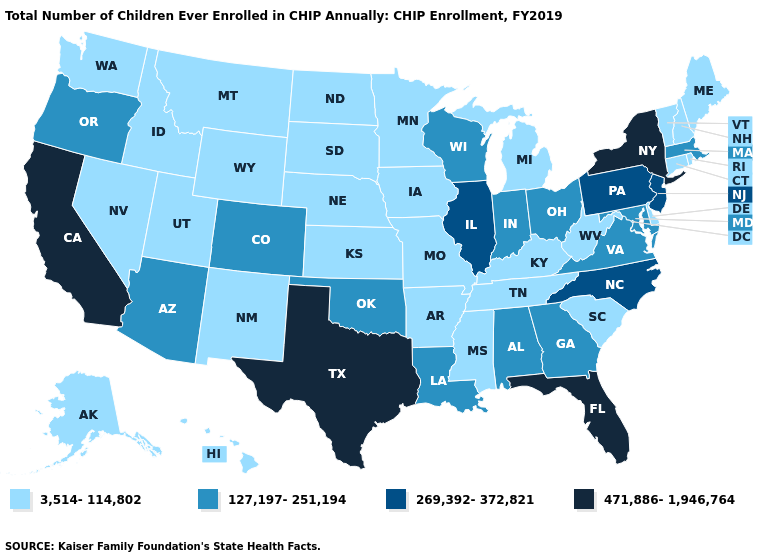Which states hav the highest value in the South?
Be succinct. Florida, Texas. Does Arizona have the lowest value in the West?
Answer briefly. No. Which states hav the highest value in the MidWest?
Give a very brief answer. Illinois. How many symbols are there in the legend?
Answer briefly. 4. Name the states that have a value in the range 127,197-251,194?
Give a very brief answer. Alabama, Arizona, Colorado, Georgia, Indiana, Louisiana, Maryland, Massachusetts, Ohio, Oklahoma, Oregon, Virginia, Wisconsin. Does Utah have the lowest value in the USA?
Concise answer only. Yes. What is the value of North Carolina?
Short answer required. 269,392-372,821. How many symbols are there in the legend?
Concise answer only. 4. What is the value of Delaware?
Be succinct. 3,514-114,802. What is the lowest value in the South?
Keep it brief. 3,514-114,802. Among the states that border Vermont , which have the highest value?
Keep it brief. New York. Name the states that have a value in the range 3,514-114,802?
Write a very short answer. Alaska, Arkansas, Connecticut, Delaware, Hawaii, Idaho, Iowa, Kansas, Kentucky, Maine, Michigan, Minnesota, Mississippi, Missouri, Montana, Nebraska, Nevada, New Hampshire, New Mexico, North Dakota, Rhode Island, South Carolina, South Dakota, Tennessee, Utah, Vermont, Washington, West Virginia, Wyoming. What is the lowest value in the USA?
Keep it brief. 3,514-114,802. What is the value of Mississippi?
Keep it brief. 3,514-114,802. Name the states that have a value in the range 269,392-372,821?
Write a very short answer. Illinois, New Jersey, North Carolina, Pennsylvania. 